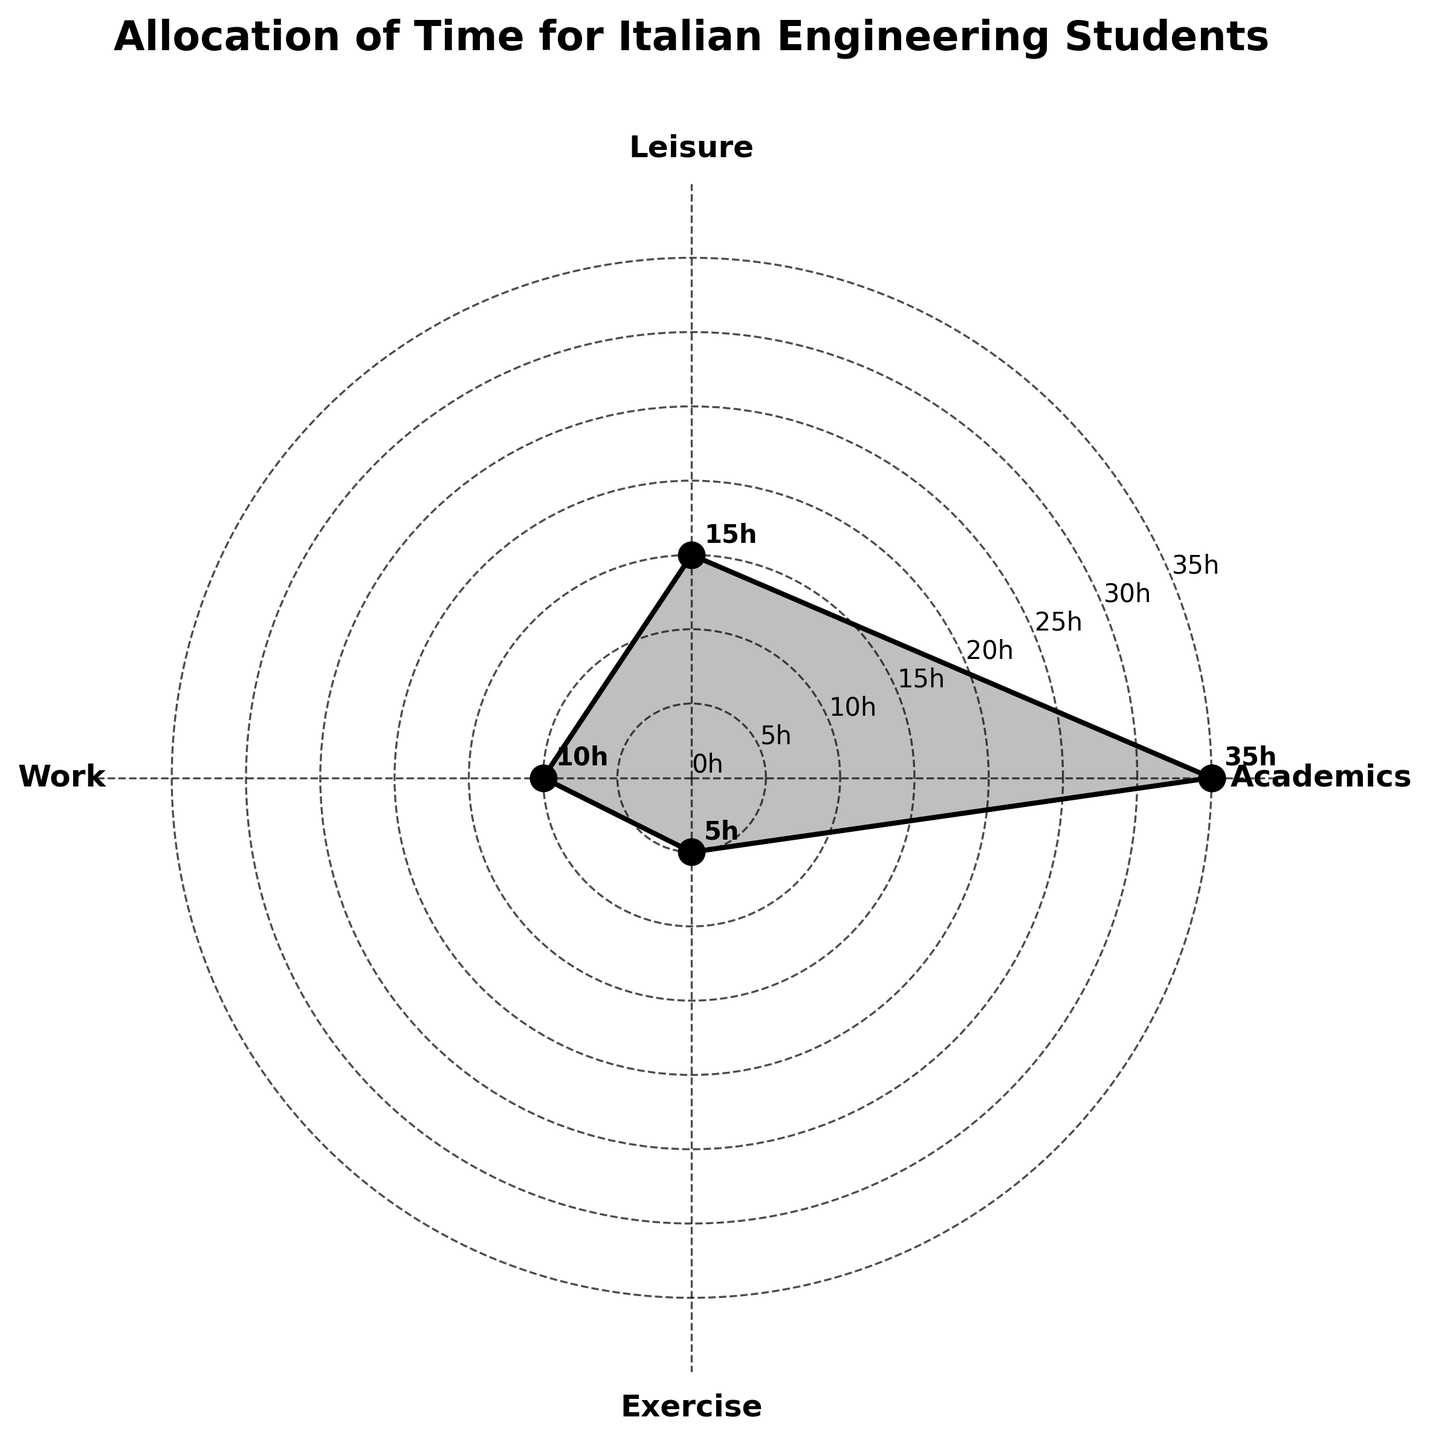What is the title of the polar area chart? The title of the chart is displayed at the top and describes what the chart represents. It is "Allocation of Time for Italian Engineering Students".
Answer: Allocation of Time for Italian Engineering Students How many activities are represented in the chart? Each segment in the polar area chart represents a different activity. By observing the labels, there are four activities: Academics, Leisure, Work, and Exercise.
Answer: 4 Which activity takes up the most hours per week? By observing the length of each segment, the longest one represents Academics at 35 hours per week.
Answer: Academics Which activity involves 15 hours per week? By looking at the chart and finding the segment labeled with 15 hours, it corresponds to Leisure.
Answer: Leisure How many hours per week are spent on Work and Exercise combined? The Work segment is 10 hours and the Exercise segment is 5 hours. Adding these together gives 10 + 5 = 15 hours.
Answer: 15 Comparing Work and Exercise, which activity has more hours, and by how much? Work has 10 hours and Exercise has 5 hours. The difference is 10 - 5 = 5 hours, so Work has more hours by 5.
Answer: Work by 5 hours What is the average number of hours spent per week across all activities? Sum the hours for all activities: 35 (Academics) + 15 (Leisure) + 10 (Work) + 5 (Exercise) = 65. There are 4 activities, so the average is 65 / 4 = 16.25 hours.
Answer: 16.25 hours What percentage of the total time is spent on Academics? Total time is 65 hours. Time spent on Academics is 35 hours. The percentage is (35 / 65) * 100 = 53.85%.
Answer: 53.85% Which two activities together take up the same amount of time as Academics? Academics accounts for 35 hours. Leisure and Work together also account for 15 + 10 = 25 hours, which is less. Leisure, Work, and Exercise together take 25 + 5 = 30 hours, which is also less. Thus, no two activities add exactly up to Academics, but Leisure, Work, and Exercise combined (3 activities) come close.
Answer: None How is the angular position of the activities in the chart determined? The positions are equally spaced around the circle, dividing the 360 degrees into four equal parts (since there are four activities). This is because it's a polar area chart.
Answer: Equally spaced around the circle 